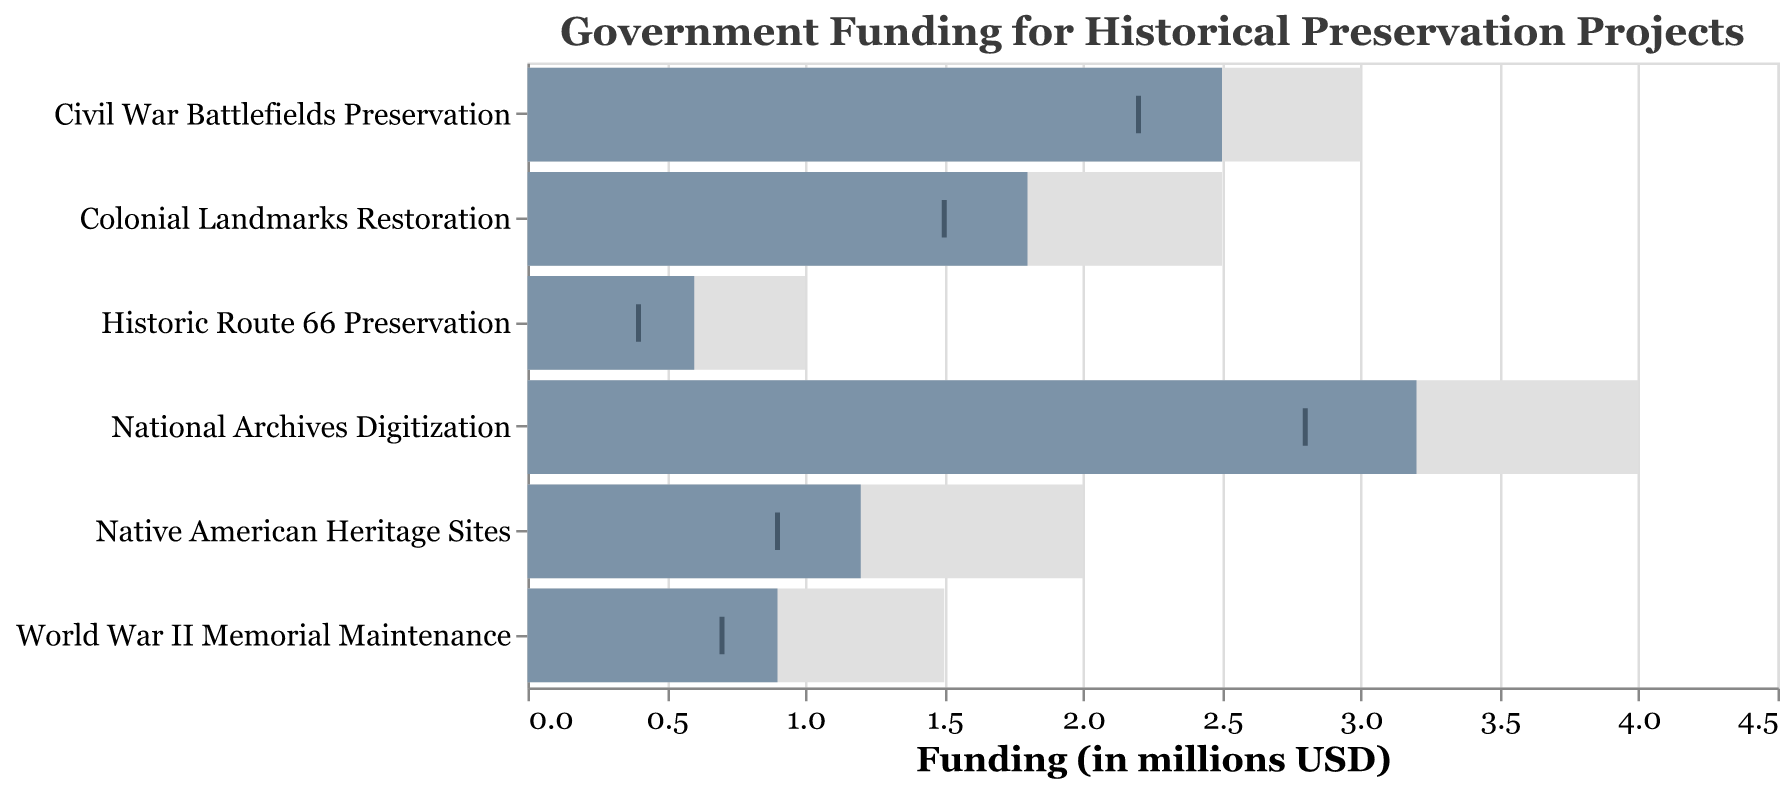What is the title of the figure? The title is displayed at the top of the figure. It provides a summary of what the chart is about.
Answer: Government Funding for Historical Preservation Projects How many historical preservation projects are represented in the chart? Each project is listed on the y-axis. By counting each label, we can determine the total number.
Answer: 6 Which project received the highest actual funding? The project with the longest dark blue bar represents the highest actual funding.
Answer: National Archives Digitization What is the target funding for Native American Heritage Sites? The length of the light gray bar for Native American Heritage Sites indicates its target funding.
Answer: 2.0 million USD Which project had the smallest actual funding compared to its target? Compare the lengths of the dark blue bars to the light gray bars. The project with the largest difference has the smallest funding compared to the target.
Answer: Native American Heritage Sites How does the actual funding for Civil War Battlefields Preservation compare to its previous year's funding? Find the position of the dark blue bar (actual funding) and the dark tick mark (previous year's funding) for Civil War Battlefields Preservation. Compare their lengths.
Answer: The actual funding (2.5 million USD) is higher than the previous year's funding (2.2 million USD) What is the difference between the target and actual funding for Colonial Landmarks Restoration? Subtract the actual funding (dark blue bar) from the target funding (light gray bar) for Colonial Landmarks Restoration.
Answer: 0.7 million USD What is the average actual funding for all projects? Sum the actual funding for each project and then divide by the number of projects. Calculation: (3.2 + 2.5 + 1.8 + 1.2 + 0.9 + 0.6) / 6.
Answer: 1.70 million USD Which project had the most significant increase in funding from the previous year to the actual funding? Compare the difference between the actual funding (dark blue bar) and the previous year's funding (dark tick mark) for each project. The project with the largest increase has the most significant rise in funding.
Answer: Native American Heritage Sites Which project falls short the most in terms of achieving its target funding? Assess which project has the largest gap between the target funding (light gray bar) and the actual funding (dark blue bar).
Answer: Native American Heritage Sites 